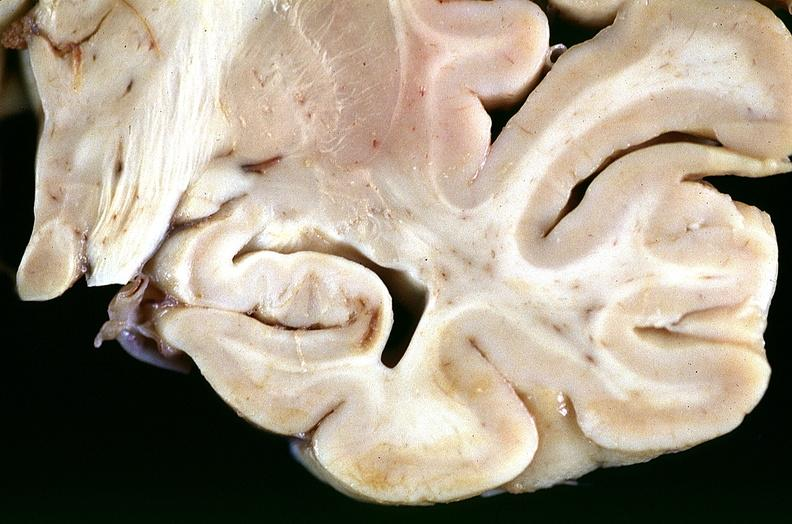does premature coronary disease show brain, infarcts, hypotension?
Answer the question using a single word or phrase. No 